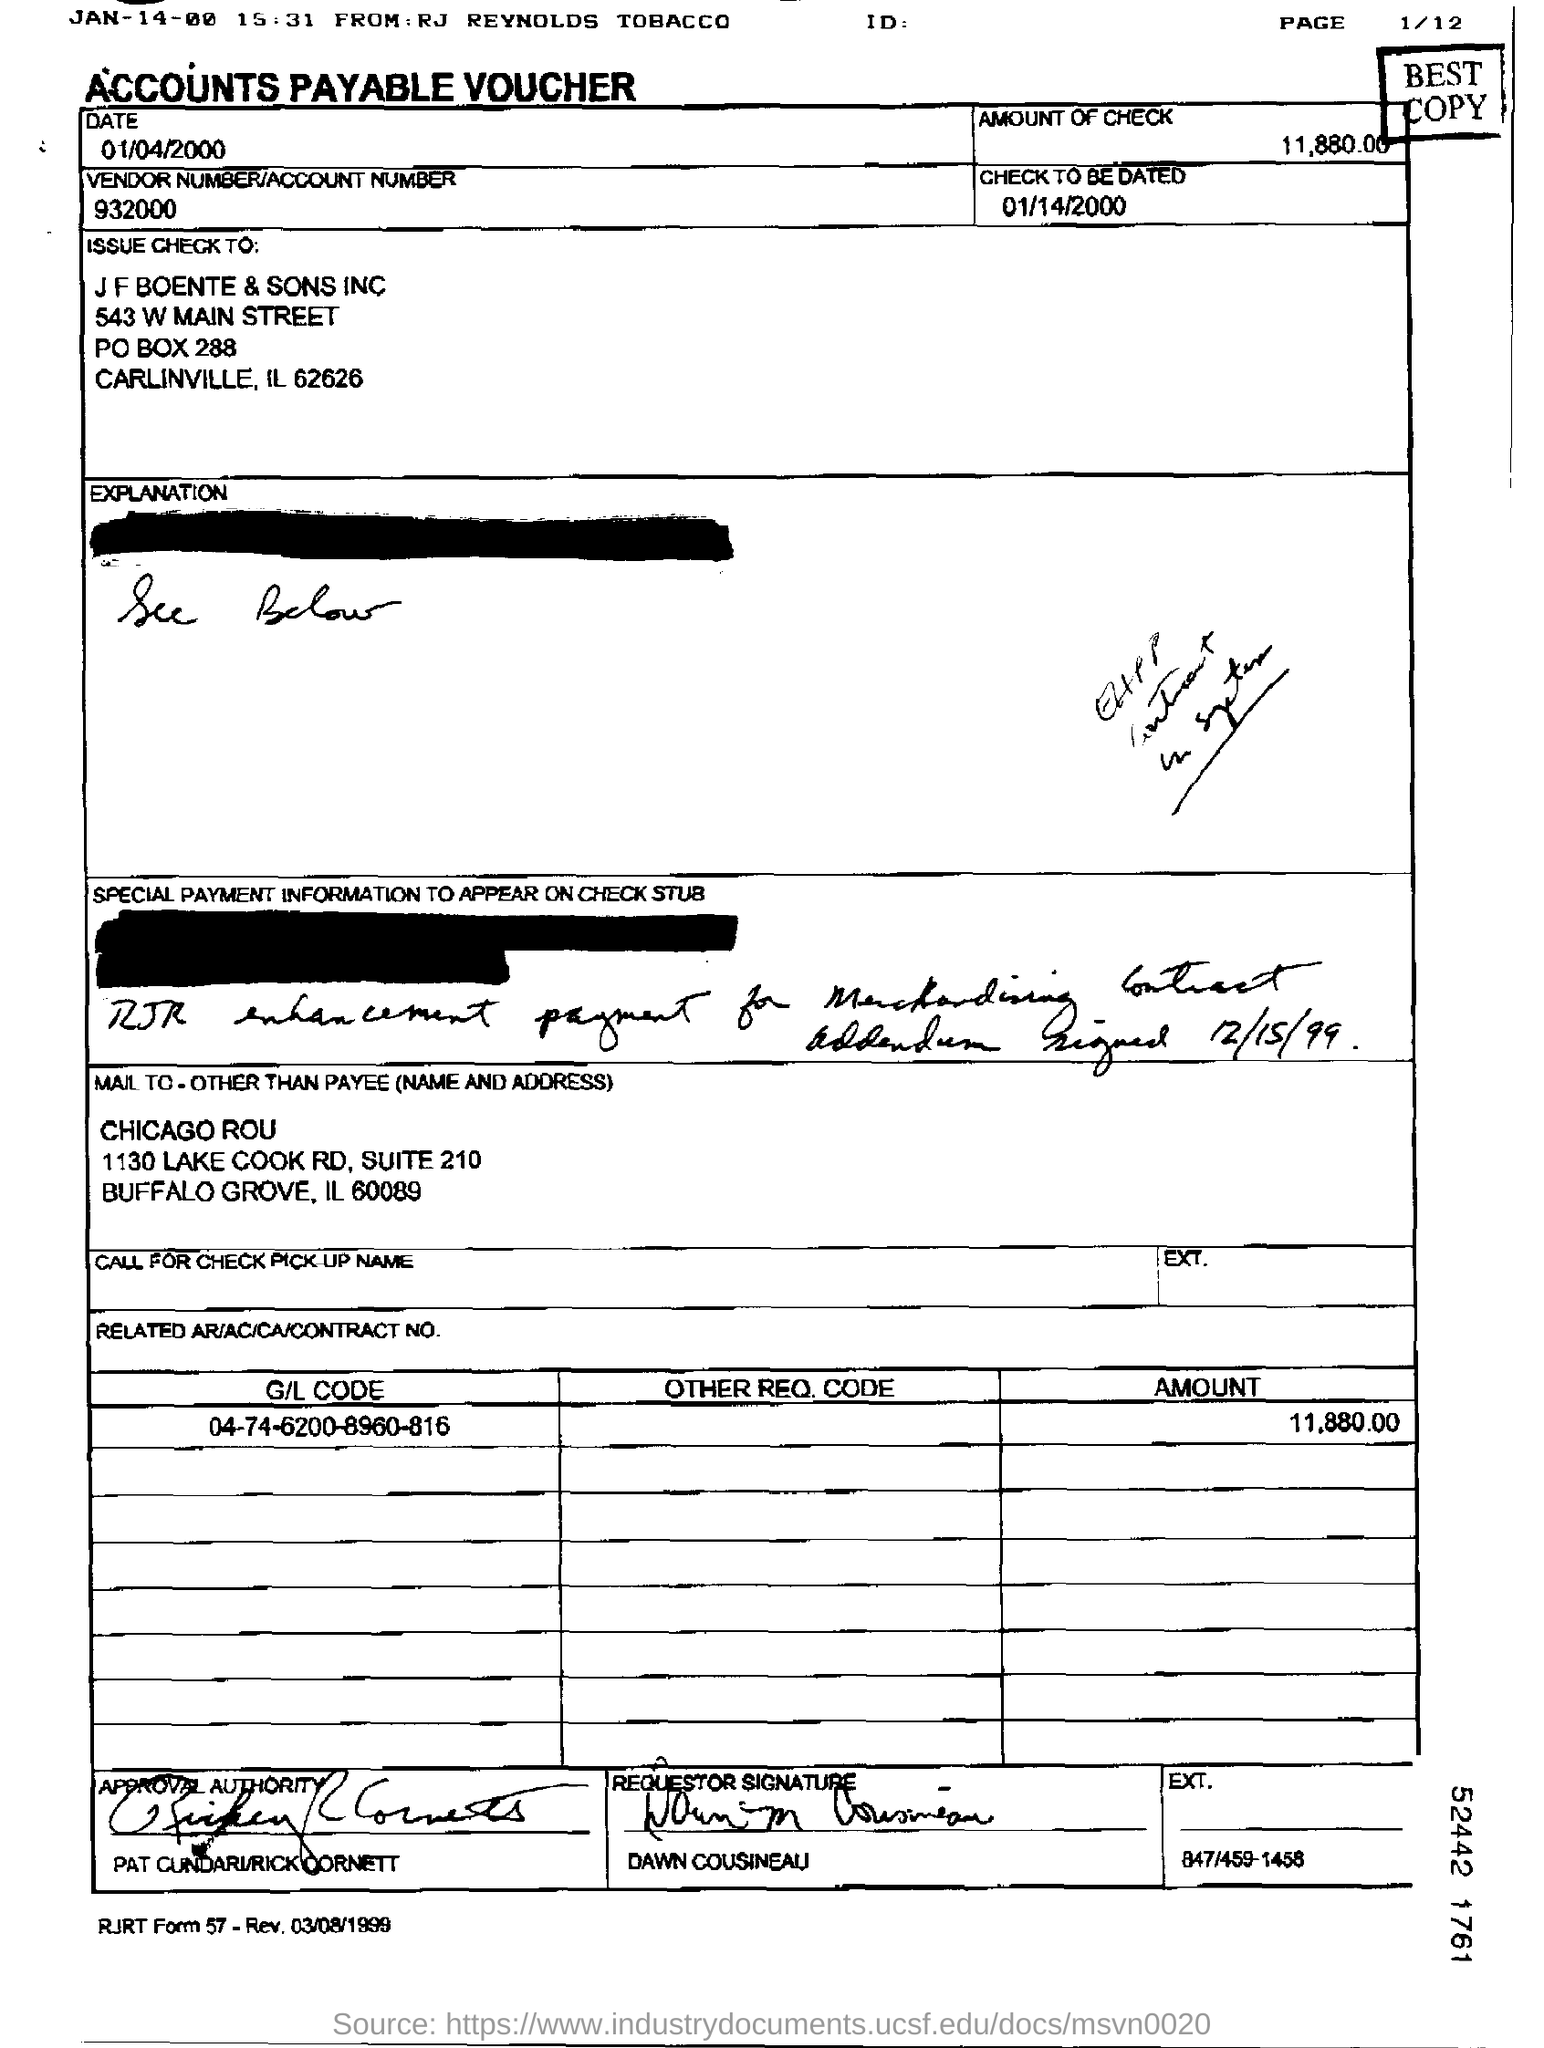Indicate a few pertinent items in this graphic. This voucher is an accounts payable voucher. Please provide the date to be checked, which is 01/14/2000. The amount of the check is 11,880.00. The vendor number/account number provided on the voucher is 932000. The G/L code mentioned in the voucher is 04-74-6200-8960-816. 